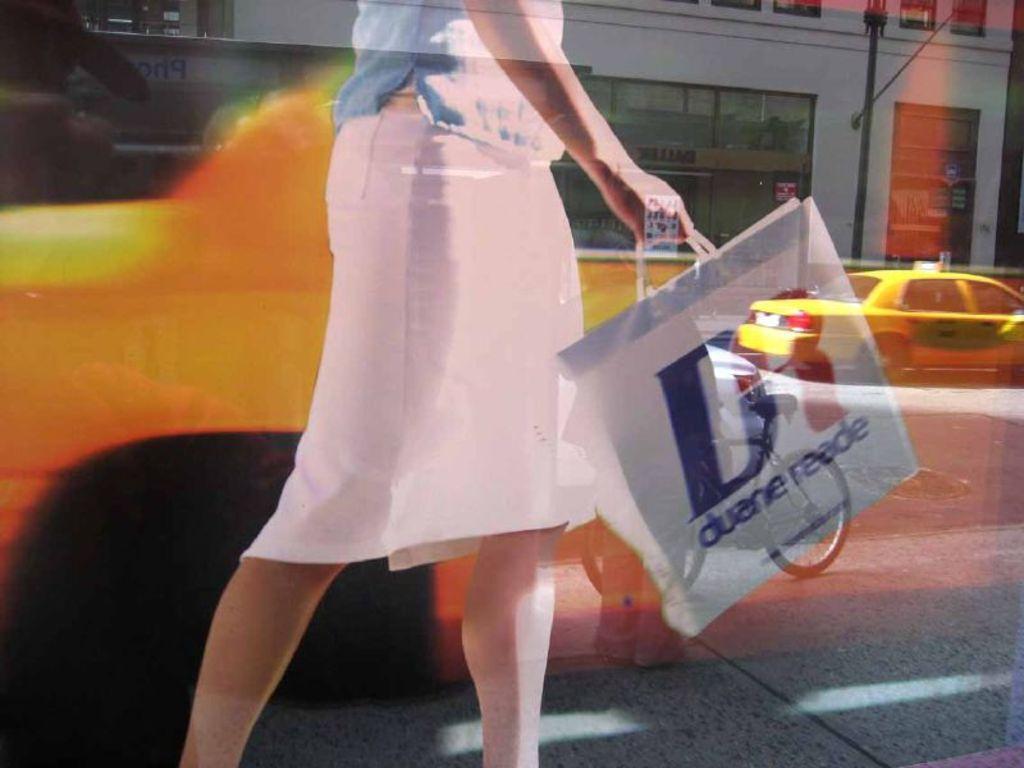What is written on the bag?
Make the answer very short. Duane reade. What does the bag say?
Ensure brevity in your answer.  Duane reade. 